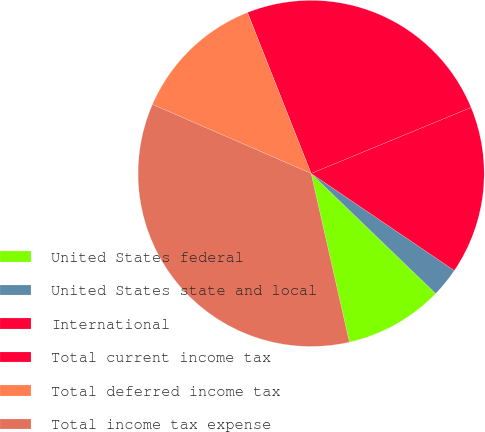Convert chart to OTSL. <chart><loc_0><loc_0><loc_500><loc_500><pie_chart><fcel>United States federal<fcel>United States state and local<fcel>International<fcel>Total current income tax<fcel>Total deferred income tax<fcel>Total income tax expense<nl><fcel>9.24%<fcel>2.73%<fcel>15.71%<fcel>24.77%<fcel>12.48%<fcel>35.08%<nl></chart> 